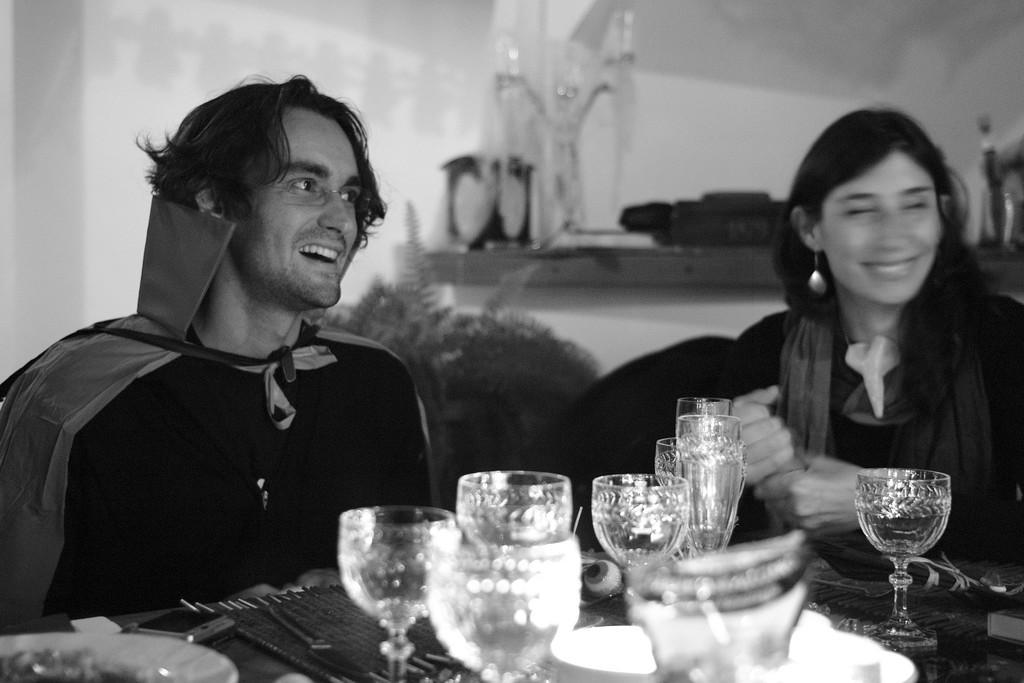In one or two sentences, can you explain what this image depicts? In this picture we can see one man and woman sitting on chair and they are smiling and in front of them we can see glasses, wall, plate, mobile, knife, spoons on table and in background we can see wall. 